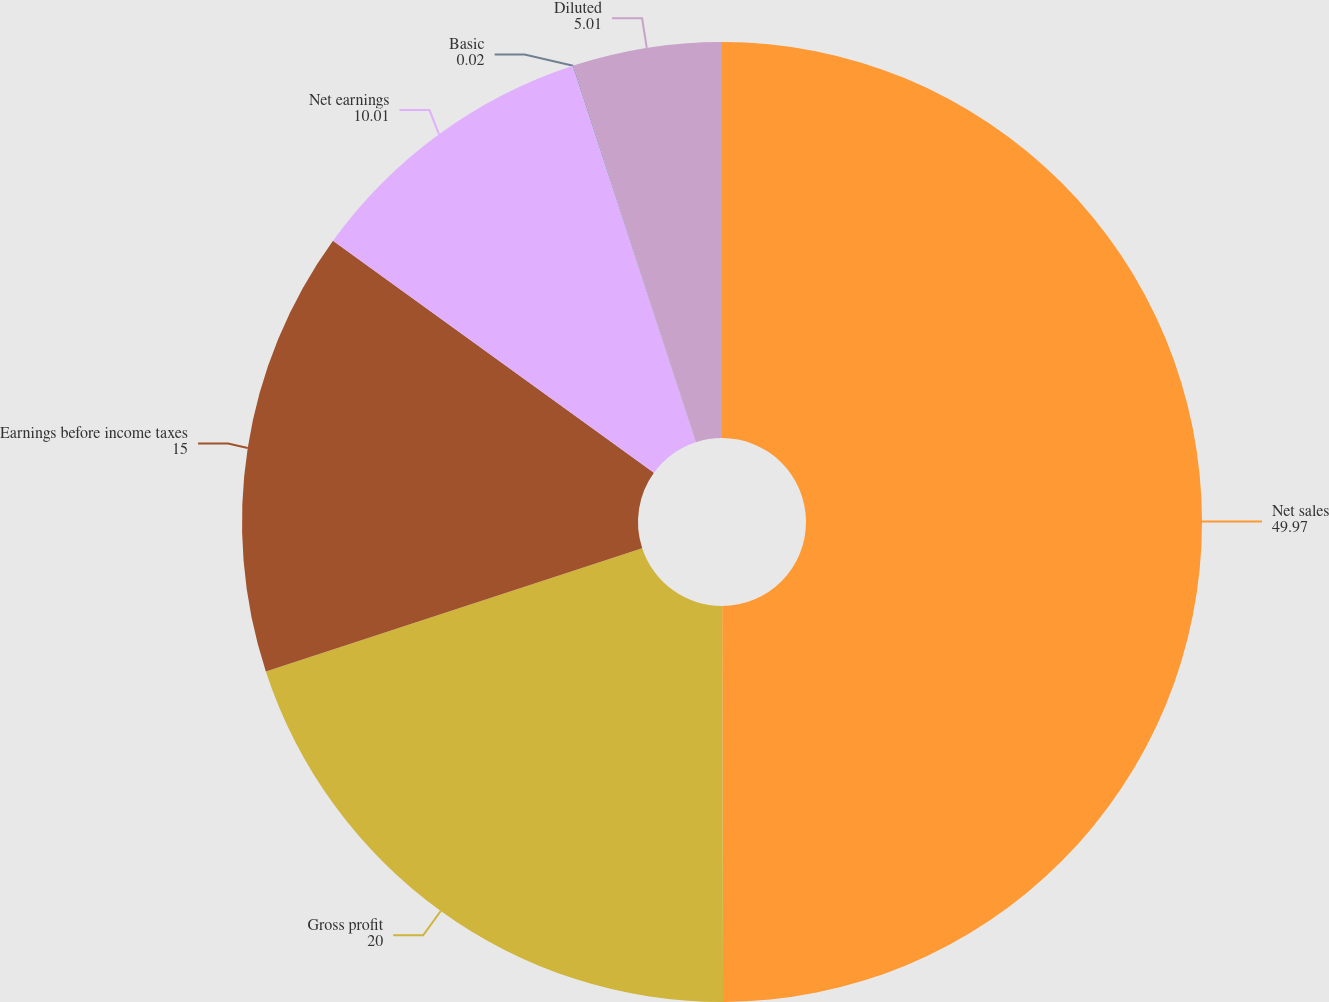Convert chart to OTSL. <chart><loc_0><loc_0><loc_500><loc_500><pie_chart><fcel>Net sales<fcel>Gross profit<fcel>Earnings before income taxes<fcel>Net earnings<fcel>Basic<fcel>Diluted<nl><fcel>49.97%<fcel>20.0%<fcel>15.0%<fcel>10.01%<fcel>0.02%<fcel>5.01%<nl></chart> 